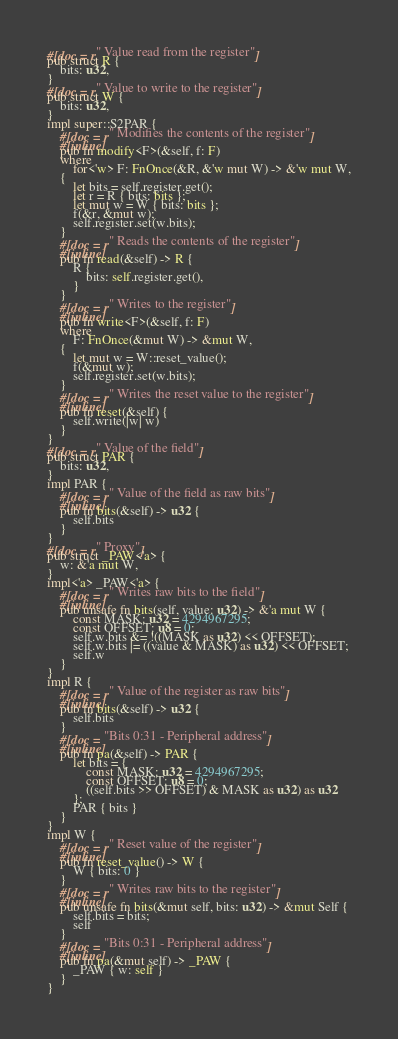<code> <loc_0><loc_0><loc_500><loc_500><_Rust_>#[doc = r" Value read from the register"]
pub struct R {
    bits: u32,
}
#[doc = r" Value to write to the register"]
pub struct W {
    bits: u32,
}
impl super::S2PAR {
    #[doc = r" Modifies the contents of the register"]
    #[inline]
    pub fn modify<F>(&self, f: F)
    where
        for<'w> F: FnOnce(&R, &'w mut W) -> &'w mut W,
    {
        let bits = self.register.get();
        let r = R { bits: bits };
        let mut w = W { bits: bits };
        f(&r, &mut w);
        self.register.set(w.bits);
    }
    #[doc = r" Reads the contents of the register"]
    #[inline]
    pub fn read(&self) -> R {
        R {
            bits: self.register.get(),
        }
    }
    #[doc = r" Writes to the register"]
    #[inline]
    pub fn write<F>(&self, f: F)
    where
        F: FnOnce(&mut W) -> &mut W,
    {
        let mut w = W::reset_value();
        f(&mut w);
        self.register.set(w.bits);
    }
    #[doc = r" Writes the reset value to the register"]
    #[inline]
    pub fn reset(&self) {
        self.write(|w| w)
    }
}
#[doc = r" Value of the field"]
pub struct PAR {
    bits: u32,
}
impl PAR {
    #[doc = r" Value of the field as raw bits"]
    #[inline]
    pub fn bits(&self) -> u32 {
        self.bits
    }
}
#[doc = r" Proxy"]
pub struct _PAW<'a> {
    w: &'a mut W,
}
impl<'a> _PAW<'a> {
    #[doc = r" Writes raw bits to the field"]
    #[inline]
    pub unsafe fn bits(self, value: u32) -> &'a mut W {
        const MASK: u32 = 4294967295;
        const OFFSET: u8 = 0;
        self.w.bits &= !((MASK as u32) << OFFSET);
        self.w.bits |= ((value & MASK) as u32) << OFFSET;
        self.w
    }
}
impl R {
    #[doc = r" Value of the register as raw bits"]
    #[inline]
    pub fn bits(&self) -> u32 {
        self.bits
    }
    #[doc = "Bits 0:31 - Peripheral address"]
    #[inline]
    pub fn pa(&self) -> PAR {
        let bits = {
            const MASK: u32 = 4294967295;
            const OFFSET: u8 = 0;
            ((self.bits >> OFFSET) & MASK as u32) as u32
        };
        PAR { bits }
    }
}
impl W {
    #[doc = r" Reset value of the register"]
    #[inline]
    pub fn reset_value() -> W {
        W { bits: 0 }
    }
    #[doc = r" Writes raw bits to the register"]
    #[inline]
    pub unsafe fn bits(&mut self, bits: u32) -> &mut Self {
        self.bits = bits;
        self
    }
    #[doc = "Bits 0:31 - Peripheral address"]
    #[inline]
    pub fn pa(&mut self) -> _PAW {
        _PAW { w: self }
    }
}
</code> 